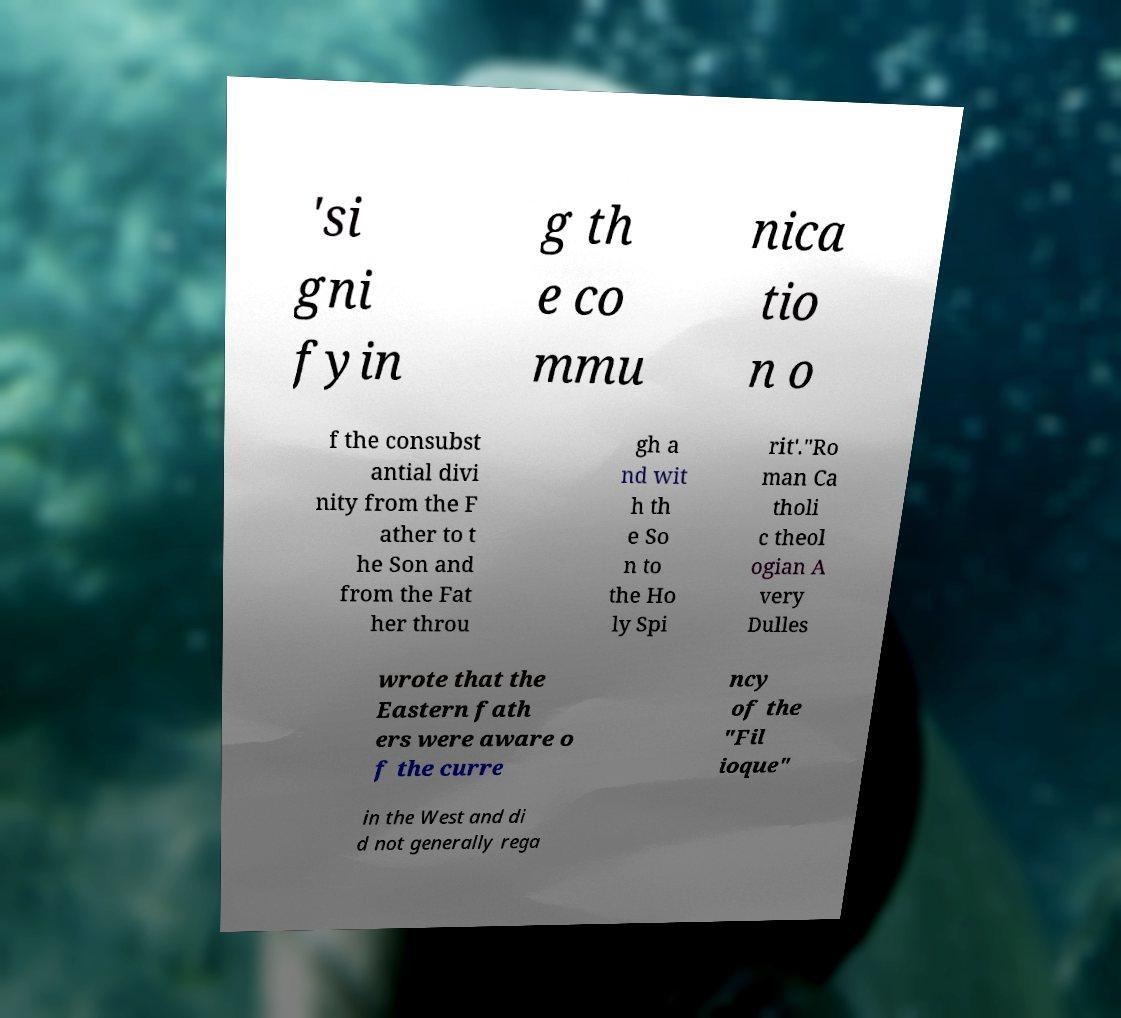What messages or text are displayed in this image? I need them in a readable, typed format. 'si gni fyin g th e co mmu nica tio n o f the consubst antial divi nity from the F ather to t he Son and from the Fat her throu gh a nd wit h th e So n to the Ho ly Spi rit'."Ro man Ca tholi c theol ogian A very Dulles wrote that the Eastern fath ers were aware o f the curre ncy of the "Fil ioque" in the West and di d not generally rega 